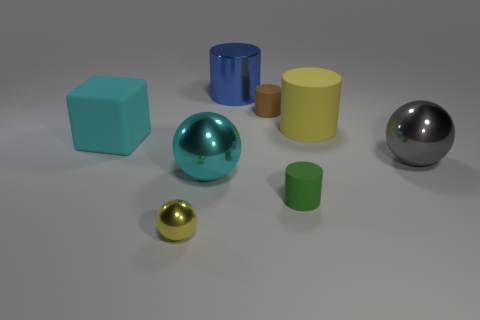Does the tiny ball have the same color as the large matte cylinder?
Give a very brief answer. Yes. Is there any other thing that is the same color as the metal cylinder?
Make the answer very short. No. There is a small green object that is the same shape as the big yellow matte object; what is it made of?
Provide a succinct answer. Rubber. Is the material of the big cyan block the same as the big cylinder that is to the left of the tiny green rubber cylinder?
Your answer should be very brief. No. There is a yellow thing behind the small matte object that is in front of the large gray object; what shape is it?
Offer a very short reply. Cylinder. What number of large things are metal objects or cyan metallic objects?
Your answer should be very brief. 3. How many other small rubber things have the same shape as the yellow rubber object?
Provide a succinct answer. 2. Do the gray thing and the yellow object that is in front of the large block have the same shape?
Make the answer very short. Yes. There is a big yellow rubber object; what number of objects are in front of it?
Offer a terse response. 5. Are there any green cylinders of the same size as the yellow shiny ball?
Keep it short and to the point. Yes. 